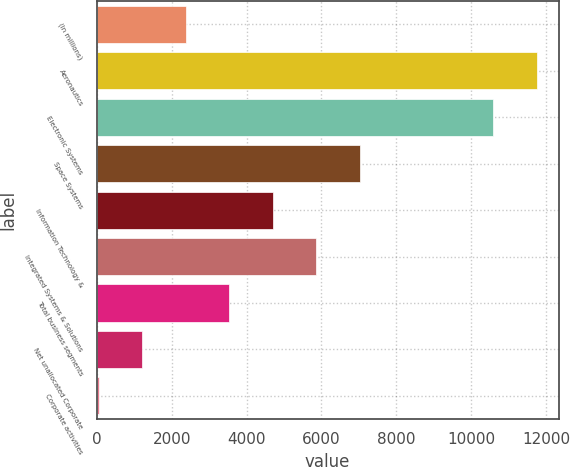Convert chart to OTSL. <chart><loc_0><loc_0><loc_500><loc_500><bar_chart><fcel>(In millions)<fcel>Aeronautics<fcel>Electronic Systems<fcel>Space Systems<fcel>Information Technology &<fcel>Integrated Systems & Solutions<fcel>Total business segments<fcel>Net unallocated Corporate<fcel>Corporate activities<nl><fcel>2375.2<fcel>11742.1<fcel>10580<fcel>7023.6<fcel>4699.4<fcel>5861.5<fcel>3537.3<fcel>1213.1<fcel>51<nl></chart> 